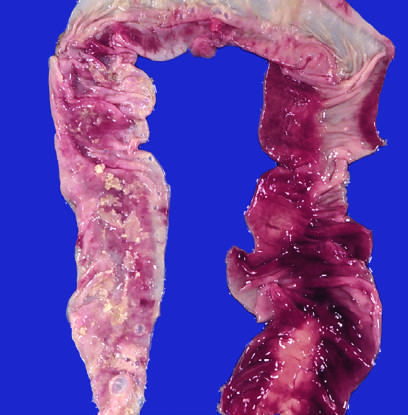does the b-cell antigen receptor complex correspond to areas of hemorrhagic infarction and transmural necrosis?
Answer the question using a single word or phrase. No 